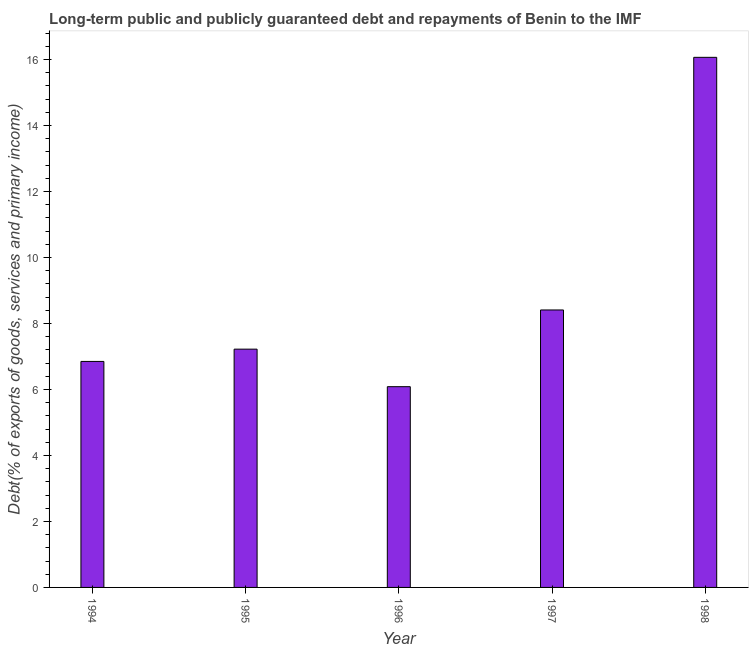Does the graph contain any zero values?
Offer a terse response. No. What is the title of the graph?
Your response must be concise. Long-term public and publicly guaranteed debt and repayments of Benin to the IMF. What is the label or title of the Y-axis?
Your response must be concise. Debt(% of exports of goods, services and primary income). What is the debt service in 1996?
Offer a terse response. 6.09. Across all years, what is the maximum debt service?
Offer a very short reply. 16.07. Across all years, what is the minimum debt service?
Offer a terse response. 6.09. In which year was the debt service maximum?
Offer a terse response. 1998. What is the sum of the debt service?
Provide a succinct answer. 44.64. What is the difference between the debt service in 1994 and 1996?
Offer a very short reply. 0.77. What is the average debt service per year?
Provide a succinct answer. 8.93. What is the median debt service?
Offer a terse response. 7.22. Do a majority of the years between 1994 and 1997 (inclusive) have debt service greater than 12.4 %?
Keep it short and to the point. No. What is the ratio of the debt service in 1996 to that in 1997?
Make the answer very short. 0.72. Is the difference between the debt service in 1994 and 1996 greater than the difference between any two years?
Provide a short and direct response. No. What is the difference between the highest and the second highest debt service?
Keep it short and to the point. 7.66. Is the sum of the debt service in 1995 and 1998 greater than the maximum debt service across all years?
Your response must be concise. Yes. What is the difference between the highest and the lowest debt service?
Ensure brevity in your answer.  9.98. How many bars are there?
Give a very brief answer. 5. Are all the bars in the graph horizontal?
Provide a succinct answer. No. How many years are there in the graph?
Ensure brevity in your answer.  5. What is the Debt(% of exports of goods, services and primary income) in 1994?
Ensure brevity in your answer.  6.85. What is the Debt(% of exports of goods, services and primary income) in 1995?
Keep it short and to the point. 7.22. What is the Debt(% of exports of goods, services and primary income) of 1996?
Offer a terse response. 6.09. What is the Debt(% of exports of goods, services and primary income) in 1997?
Your response must be concise. 8.41. What is the Debt(% of exports of goods, services and primary income) of 1998?
Your answer should be compact. 16.07. What is the difference between the Debt(% of exports of goods, services and primary income) in 1994 and 1995?
Offer a terse response. -0.37. What is the difference between the Debt(% of exports of goods, services and primary income) in 1994 and 1996?
Keep it short and to the point. 0.77. What is the difference between the Debt(% of exports of goods, services and primary income) in 1994 and 1997?
Offer a terse response. -1.56. What is the difference between the Debt(% of exports of goods, services and primary income) in 1994 and 1998?
Give a very brief answer. -9.22. What is the difference between the Debt(% of exports of goods, services and primary income) in 1995 and 1996?
Provide a short and direct response. 1.14. What is the difference between the Debt(% of exports of goods, services and primary income) in 1995 and 1997?
Give a very brief answer. -1.19. What is the difference between the Debt(% of exports of goods, services and primary income) in 1995 and 1998?
Your answer should be compact. -8.85. What is the difference between the Debt(% of exports of goods, services and primary income) in 1996 and 1997?
Your answer should be compact. -2.33. What is the difference between the Debt(% of exports of goods, services and primary income) in 1996 and 1998?
Your answer should be very brief. -9.98. What is the difference between the Debt(% of exports of goods, services and primary income) in 1997 and 1998?
Give a very brief answer. -7.66. What is the ratio of the Debt(% of exports of goods, services and primary income) in 1994 to that in 1995?
Keep it short and to the point. 0.95. What is the ratio of the Debt(% of exports of goods, services and primary income) in 1994 to that in 1996?
Provide a succinct answer. 1.13. What is the ratio of the Debt(% of exports of goods, services and primary income) in 1994 to that in 1997?
Provide a short and direct response. 0.81. What is the ratio of the Debt(% of exports of goods, services and primary income) in 1994 to that in 1998?
Your answer should be compact. 0.43. What is the ratio of the Debt(% of exports of goods, services and primary income) in 1995 to that in 1996?
Provide a short and direct response. 1.19. What is the ratio of the Debt(% of exports of goods, services and primary income) in 1995 to that in 1997?
Ensure brevity in your answer.  0.86. What is the ratio of the Debt(% of exports of goods, services and primary income) in 1995 to that in 1998?
Provide a succinct answer. 0.45. What is the ratio of the Debt(% of exports of goods, services and primary income) in 1996 to that in 1997?
Make the answer very short. 0.72. What is the ratio of the Debt(% of exports of goods, services and primary income) in 1996 to that in 1998?
Offer a terse response. 0.38. What is the ratio of the Debt(% of exports of goods, services and primary income) in 1997 to that in 1998?
Ensure brevity in your answer.  0.52. 